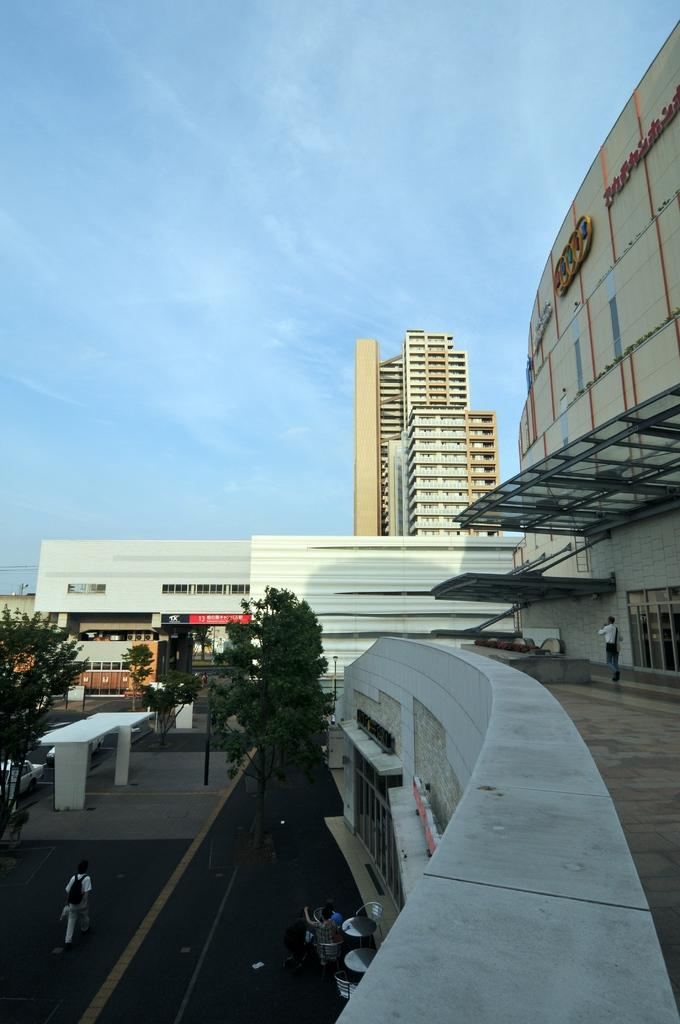What are the people in the image doing? The people in the image are walking on the road. What type of vegetation can be seen in the image? There are trees with green color in the image. What colors are the buildings in the image? The buildings in the image have white and cream colors. What is the color of the sky in the image? The sky is in blue color in the image. Can you see the minister walking with the group in the image? There is no mention of a minister or a group in the image; it only shows people walking on the road, trees, buildings, and the sky. 